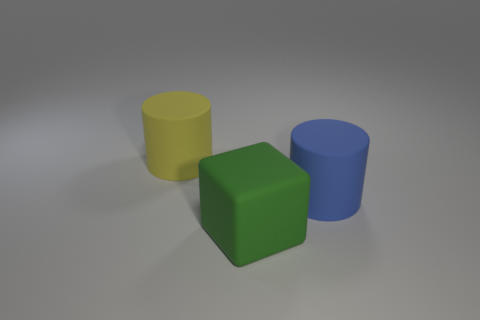Add 3 big brown matte cubes. How many objects exist? 6 Subtract all blue cylinders. How many cylinders are left? 1 Subtract all cylinders. How many objects are left? 1 Add 1 large rubber cubes. How many large rubber cubes are left? 2 Add 1 green blocks. How many green blocks exist? 2 Subtract 0 green cylinders. How many objects are left? 3 Subtract all purple cylinders. Subtract all brown balls. How many cylinders are left? 2 Subtract all big things. Subtract all red spheres. How many objects are left? 0 